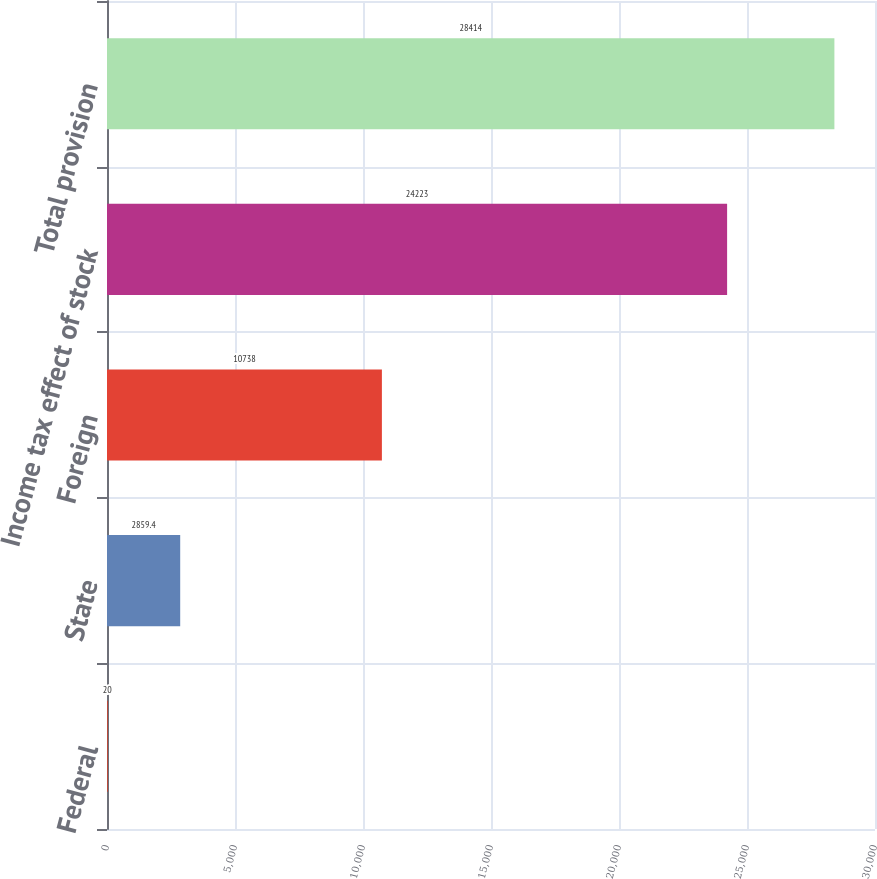Convert chart. <chart><loc_0><loc_0><loc_500><loc_500><bar_chart><fcel>Federal<fcel>State<fcel>Foreign<fcel>Income tax effect of stock<fcel>Total provision<nl><fcel>20<fcel>2859.4<fcel>10738<fcel>24223<fcel>28414<nl></chart> 